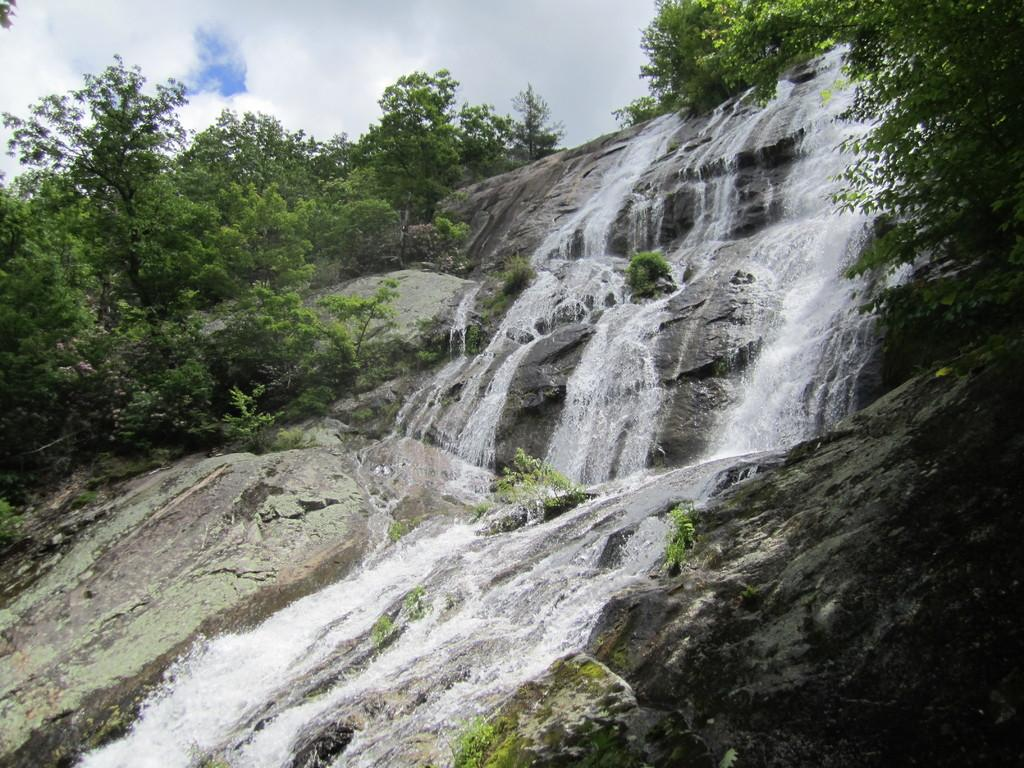What natural feature is the main subject of the image? There is a waterfall in the image. What type of vegetation can be seen in the image? There are trees in the image. What is visible in the sky in the image? Clouds and the sky are visible in the image. What type of cake is being served at night to reward the hikers in the image? There is no cake, night, or hikers present in the image; it features a waterfall, trees, clouds, and the sky. 